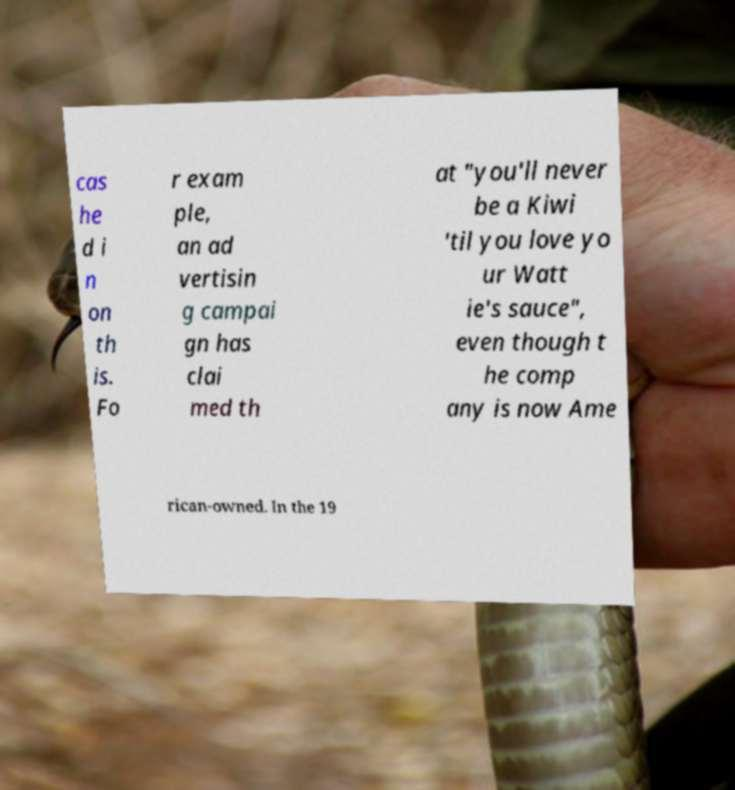Can you read and provide the text displayed in the image?This photo seems to have some interesting text. Can you extract and type it out for me? cas he d i n on th is. Fo r exam ple, an ad vertisin g campai gn has clai med th at "you'll never be a Kiwi 'til you love yo ur Watt ie's sauce", even though t he comp any is now Ame rican-owned. In the 19 